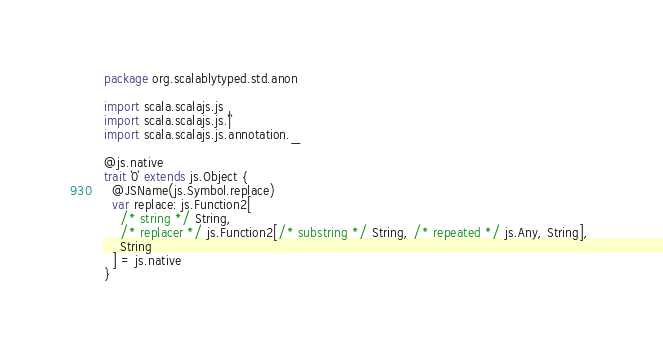<code> <loc_0><loc_0><loc_500><loc_500><_Scala_>package org.scalablytyped.std.anon

import scala.scalajs.js
import scala.scalajs.js.`|`
import scala.scalajs.js.annotation._

@js.native
trait `0` extends js.Object {
  @JSName(js.Symbol.replace)
  var replace: js.Function2[
    /* string */ String, 
    /* replacer */ js.Function2[/* substring */ String, /* repeated */ js.Any, String], 
    String
  ] = js.native
}

</code> 